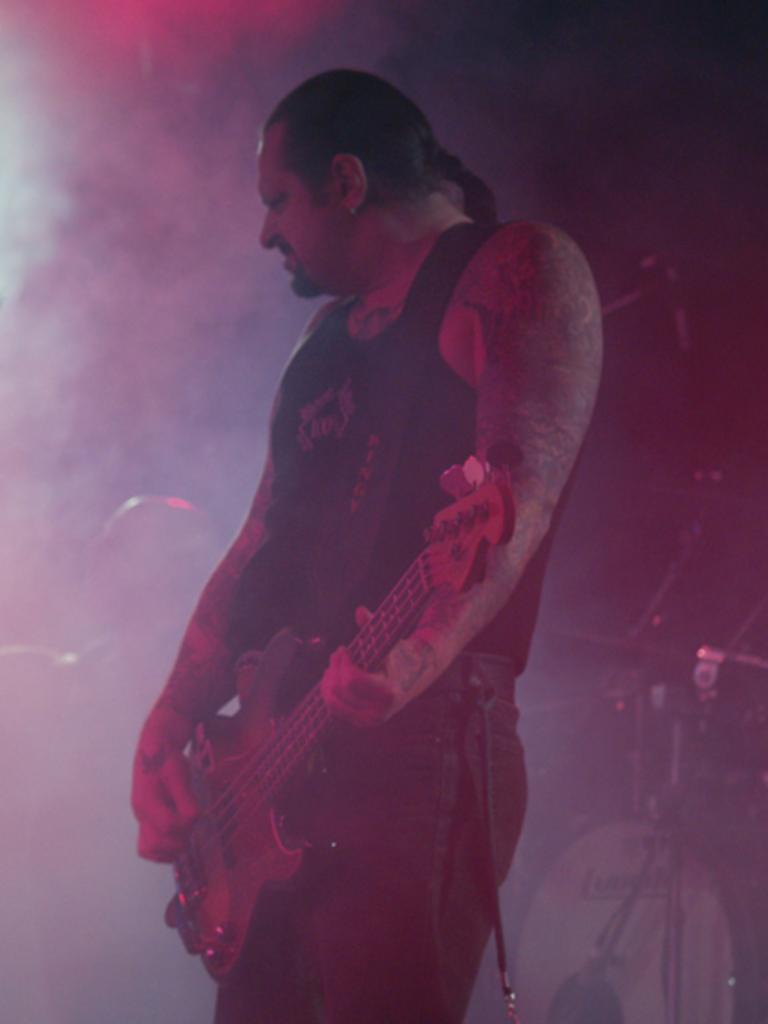What is the man in the image doing? The man is standing and playing a guitar. What can be seen in the background of the image? There are musical instruments in the background. Can you describe the position of the person in the image? There is a person sitting at the back. What type of camera can be seen in the image? There is no camera present in the image. Can you tell me which actor is playing the guitar in the image? The image does not depict a specific actor; it shows a man playing the guitar. 